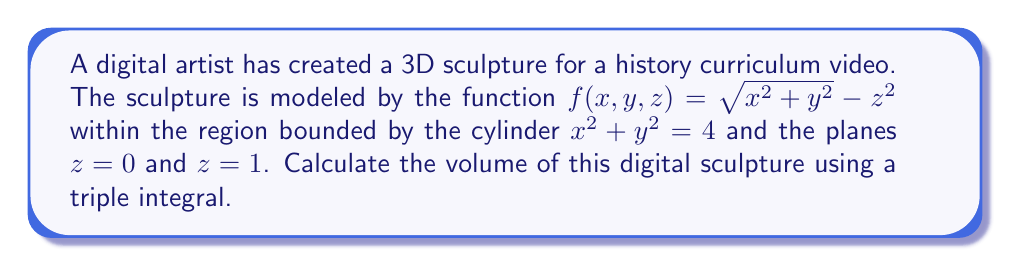Provide a solution to this math problem. To calculate the volume of the 3D sculpture, we need to set up and evaluate a triple integral. Let's approach this step-by-step:

1) The region is bounded by a cylinder $x^2 + y^2 = 4$, which suggests using cylindrical coordinates $(r, \theta, z)$ for easier integration.

2) In cylindrical coordinates:
   $x = r\cos\theta$
   $y = r\sin\theta$
   $z = z$

3) The bounds of integration are:
   $0 \leq r \leq 2$ (from the cylinder equation)
   $0 \leq \theta \leq 2\pi$ (full circle)
   $0 \leq z \leq 1$ (from the given planes)

4) The volume element in cylindrical coordinates is $r \, dr \, d\theta \, dz$.

5) The integral to calculate the volume is:

   $$V = \int_0^1 \int_0^{2\pi} \int_0^2 (\sqrt{r^2} - z^2) r \, dr \, d\theta \, dz$$

6) Simplify $\sqrt{r^2} = r$:

   $$V = \int_0^1 \int_0^{2\pi} \int_0^2 (r^2 - rz^2) \, dr \, d\theta \, dz$$

7) Integrate with respect to r:

   $$V = \int_0^1 \int_0^{2\pi} \left[\frac{r^3}{3} - \frac{r^2z^2}{2}\right]_0^2 \, d\theta \, dz$$

   $$V = \int_0^1 \int_0^{2\pi} \left(\frac{8}{3} - 2z^2\right) \, d\theta \, dz$$

8) Integrate with respect to θ:

   $$V = \int_0^1 \left[\left(\frac{8}{3} - 2z^2\right)\theta\right]_0^{2\pi} \, dz$$

   $$V = \int_0^1 \left(\frac{16\pi}{3} - 4\pi z^2\right) \, dz$$

9) Finally, integrate with respect to z:

   $$V = \left[\frac{16\pi z}{3} - \frac{4\pi z^3}{3}\right]_0^1$$

   $$V = \frac{16\pi}{3} - \frac{4\pi}{3} = 4\pi$$

Therefore, the volume of the digital sculpture is $4\pi$ cubic units.
Answer: $4\pi$ cubic units 